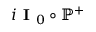Convert formula to latex. <formula><loc_0><loc_0><loc_500><loc_500>i I _ { 0 } \circ \mathbb { P } ^ { + }</formula> 